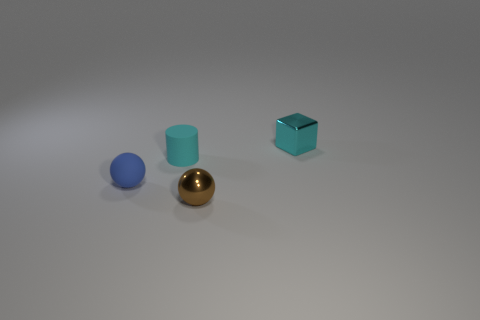What can you infer about the size and relative positions of the objects? The objects are arranged with a sense of depth. The small blue sphere at the front appears to be the smallest. The teal cylinder is slightly further back and larger in height. The golden sphere is approximately the same size as the teal cylinder but placed a bit more to the back and center. The cyan cube is the furthest to the back and to the right, positioned with its edges aligned diagonally to the viewer. It's comparable in size to the teal cylinder but with a distinctly sharp-edged shape. The spatial arrangement gives a graduated perspective, enhancing the image's depth. 